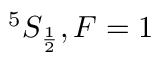Convert formula to latex. <formula><loc_0><loc_0><loc_500><loc_500>^ { 5 } S _ { \frac { 1 } { 2 } } , F = 1</formula> 